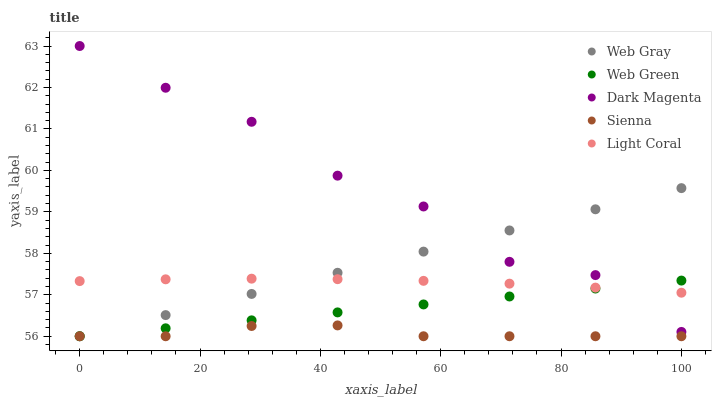Does Sienna have the minimum area under the curve?
Answer yes or no. Yes. Does Dark Magenta have the maximum area under the curve?
Answer yes or no. Yes. Does Light Coral have the minimum area under the curve?
Answer yes or no. No. Does Light Coral have the maximum area under the curve?
Answer yes or no. No. Is Web Green the smoothest?
Answer yes or no. Yes. Is Dark Magenta the roughest?
Answer yes or no. Yes. Is Light Coral the smoothest?
Answer yes or no. No. Is Light Coral the roughest?
Answer yes or no. No. Does Sienna have the lowest value?
Answer yes or no. Yes. Does Light Coral have the lowest value?
Answer yes or no. No. Does Dark Magenta have the highest value?
Answer yes or no. Yes. Does Light Coral have the highest value?
Answer yes or no. No. Is Sienna less than Light Coral?
Answer yes or no. Yes. Is Dark Magenta greater than Sienna?
Answer yes or no. Yes. Does Web Gray intersect Web Green?
Answer yes or no. Yes. Is Web Gray less than Web Green?
Answer yes or no. No. Is Web Gray greater than Web Green?
Answer yes or no. No. Does Sienna intersect Light Coral?
Answer yes or no. No. 